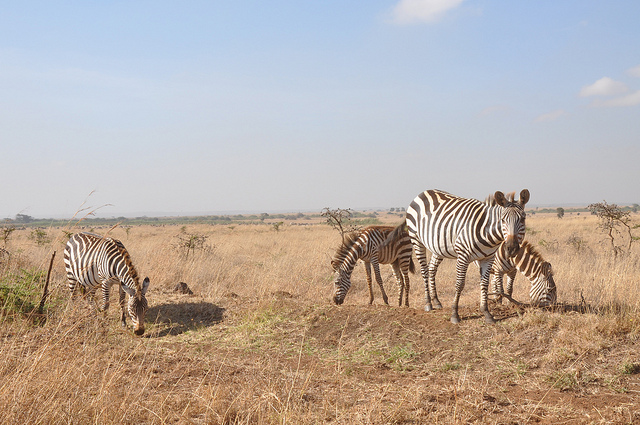<image>Is this a family of zebra? I am not sure if this is a family of zebras or not. Is this a family of zebra? I am not sure if this is a family of zebra. It can be both a family of zebra or not. 